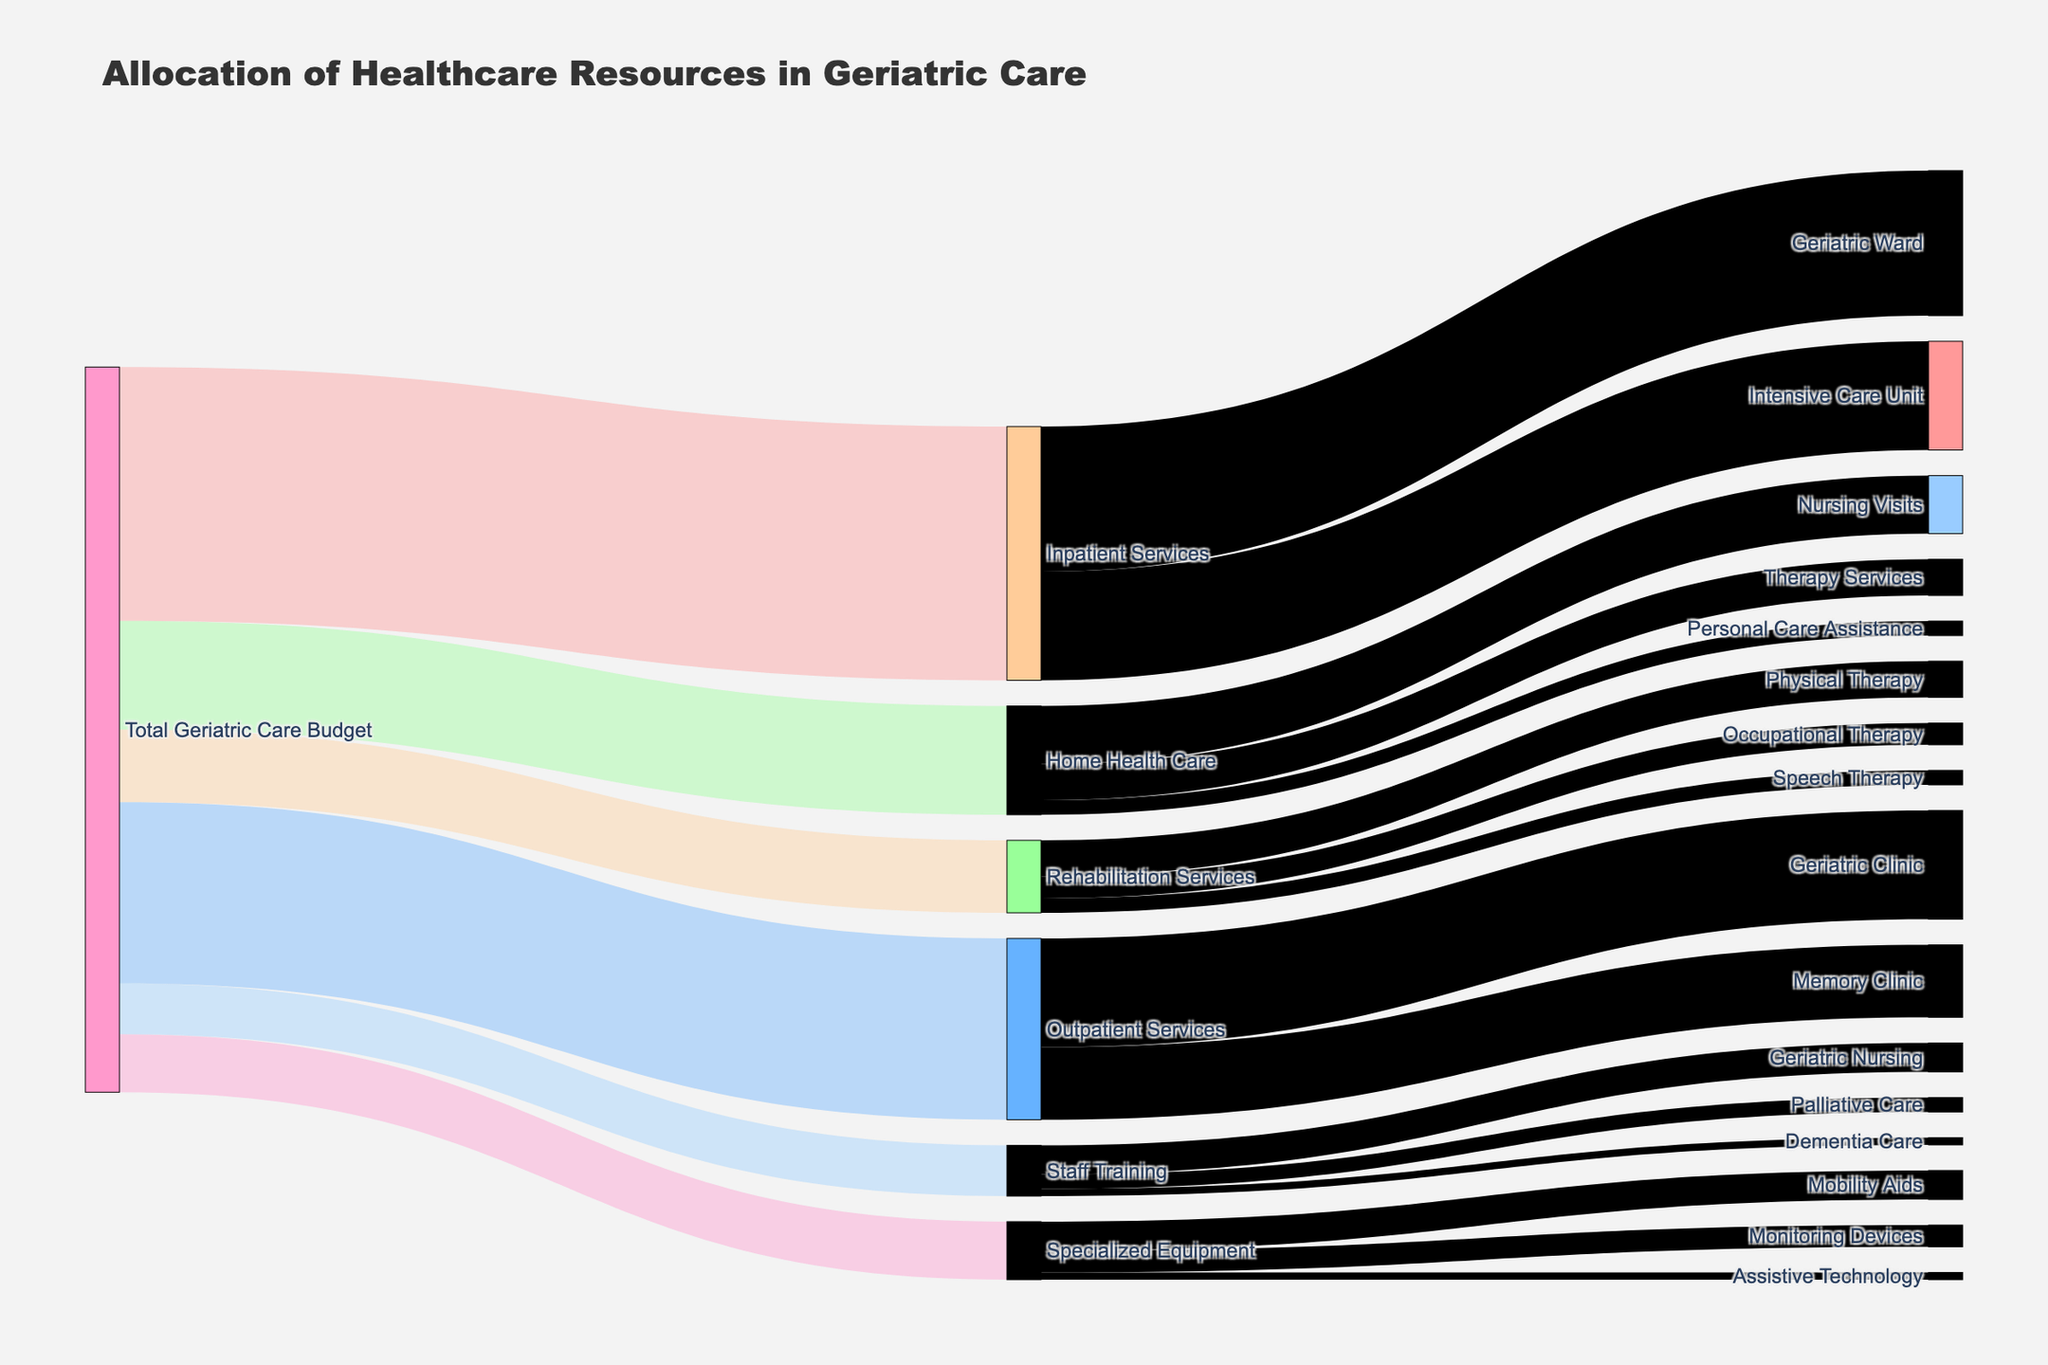what is the total budget allocated to Geriatric Care? The figure title "Allocation of Healthcare Resources in Geriatric Care" indicates this visual is about the total budget for different services. The source node "Total Geriatric Care Budget" shows the budget is split into several allocations summing up to the total.
Answer: 100,000,000 How much is allocated to Inpatient Services compared to Outpatient Services? The links from "Total Geriatric Care Budget" to "Inpatient Services" and "Outpatient Services" respectively indicate how the budget is distributed. Inpatient Services receive 35,000,000 and Outpatient Services get 25,000,000, with a 10,000,000 difference.
Answer: Inpatient Services receive 10,000,000 more What percentage of the total budget goes to Home Health Care? The total budget is 100,000,000. Home Health Care receives 15,000,000. So, (15,000,000 / 100,000,000) * 100 = 15%.
Answer: 15% Which department under Inpatient Services has a higher allocation? The links from "Inpatient Services" split into "Geriatric Ward" (20,000,000) and "Intensive Care Unit" (15,000,000). Comparing the two values, "Geriatric Ward" has a higher allocation.
Answer: Geriatric Ward What is the allocation for Specialized Equipment and its subdivisions? "Specialized Equipment" links to "Mobility Aids" (4,000,000), "Monitoring Devices" (3,000,000), and "Assistive Technology" (1,000,000). Summing these values, the total allocation is 8,000,000.
Answer: 8,000,000 How does the budget for Staff Training compare to the budget for Home Health Care? Staff Training has an allocation of 7,000,000 while Home Health Care has an allocation of 15,000,000. Staff Training receives 8,000,000 less than Home Health Care.
Answer: Staff Training receives 8,000,000 less What is the combined budget for Therapy Services across all departments? Therapy services are listed under Home Health Care (Therapy Services: 5,000,000), and Rehabilitation Services (Physical Therapy: 5,000,000, Occupational Therapy: 3,000,000, Speech Therapy: 2,000,000). Adding these gives us a total of 15,000,000.
Answer: 15,000,000 Which single service receives the highest budget allocation? By examining all the target nodes, "Geriatric Ward" under Inpatient Services receives the highest single allocation of 20,000,000.
Answer: Geriatric Ward How much is spent on memory-related services? Memory-related services include "Memory Clinic" under Outpatient Services with an allocation of 10,000,000.
Answer: 10,000,000 What is the difference between the budget allocated to Geriatric Nursing and Dementia Care training? Geriatric Nursing under Staff Training gets 4,000,000 whereas Dementia Care gets 1,000,000. The difference is 3,000,000.
Answer: 3,000,000 